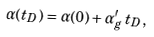<formula> <loc_0><loc_0><loc_500><loc_500>\alpha ( t _ { D } ) = \alpha ( 0 ) + \alpha ^ { \prime } _ { g } \, t _ { D } ,</formula> 